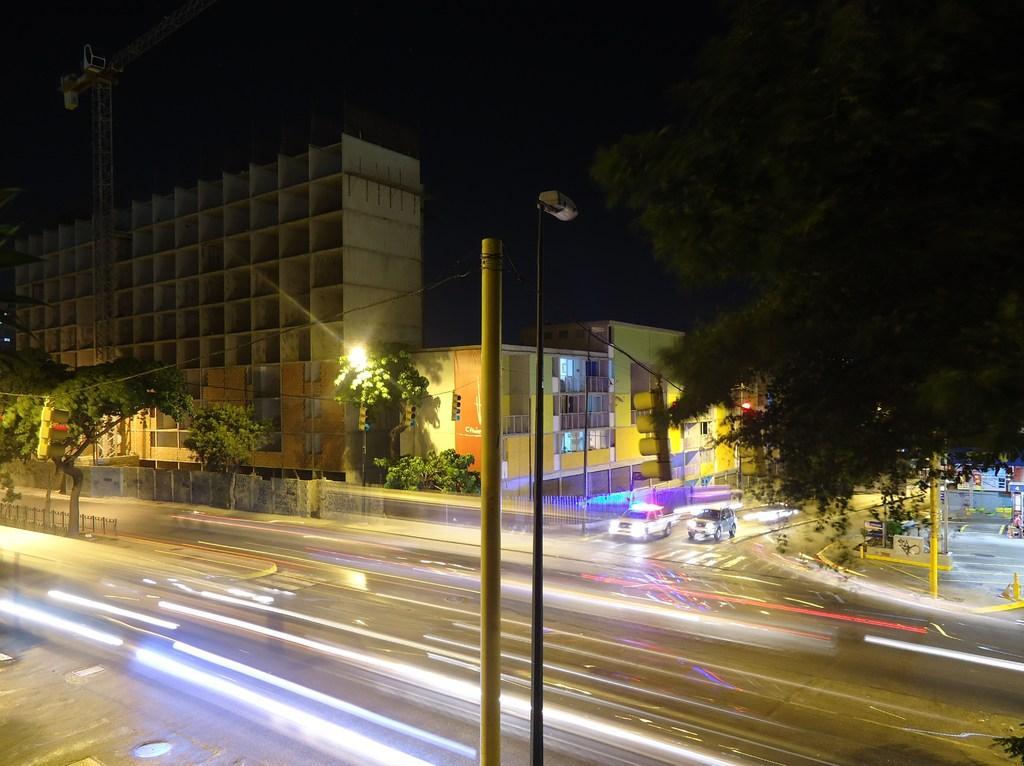In one or two sentences, can you explain what this image depicts? In the picture I can see buildings, street lights, vehicles on the road, trees, poles, fence and some other objects. In the background I can see the sky. 